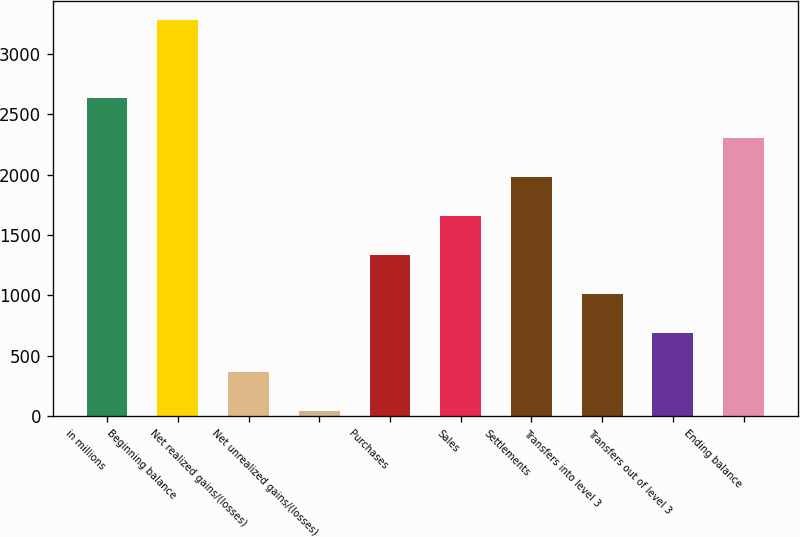Convert chart. <chart><loc_0><loc_0><loc_500><loc_500><bar_chart><fcel>in millions<fcel>Beginning balance<fcel>Net realized gains/(losses)<fcel>Net unrealized gains/(losses)<fcel>Purchases<fcel>Sales<fcel>Settlements<fcel>Transfers into level 3<fcel>Transfers out of level 3<fcel>Ending balance<nl><fcel>2628.8<fcel>3275<fcel>367.1<fcel>44<fcel>1336.4<fcel>1659.5<fcel>1982.6<fcel>1013.3<fcel>690.2<fcel>2305.7<nl></chart> 